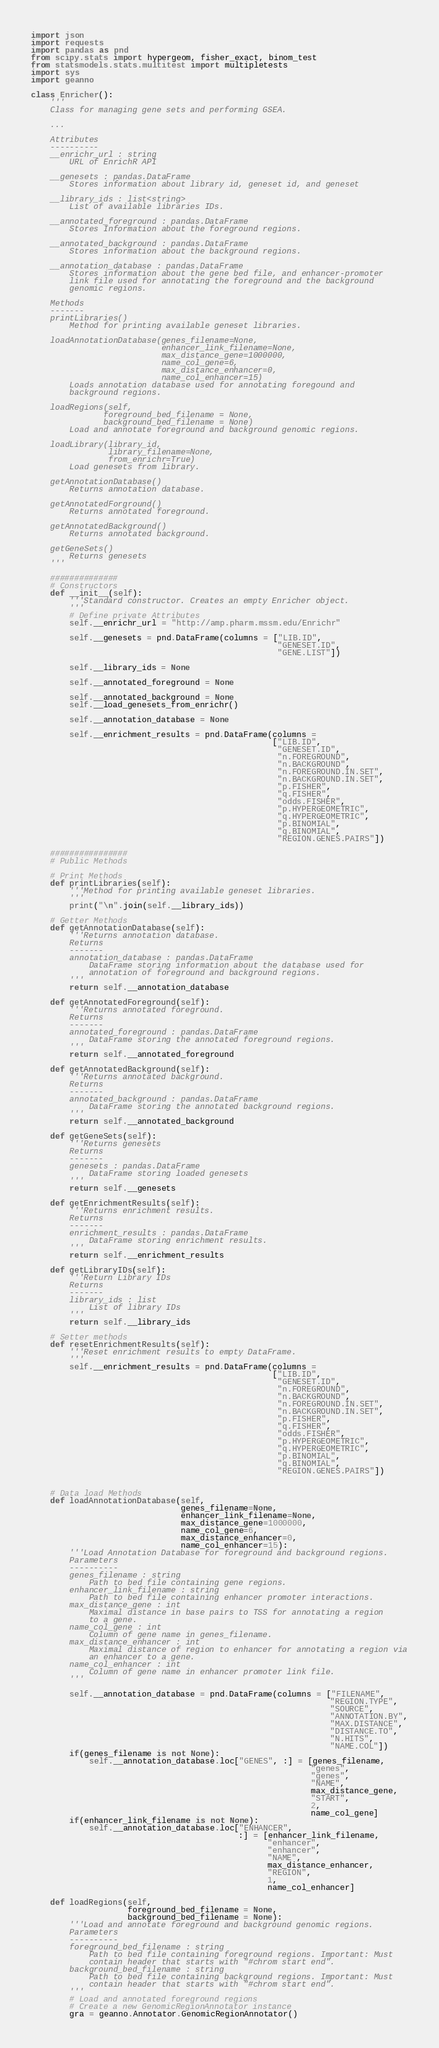<code> <loc_0><loc_0><loc_500><loc_500><_Python_>import json
import requests
import pandas as pnd
from scipy.stats import hypergeom, fisher_exact, binom_test
from statsmodels.stats.multitest import multipletests
import sys
import geanno

class Enricher():
    '''
    Class for managing gene sets and performing GSEA.

    ...

    Attributes
    ----------
    __enrichr_url : string
        URL of EnrichR API

    __genesets : pandas.DataFrame
        Stores information about library id, geneset id, and geneset

    __library_ids : list<string>
        List of available libraries IDs.

    __annotated_foreground : pandas.DataFrame
        Stores Information about the foreground regions.

    __annotated_background : pandas.DataFrame
        Stores information about the background regions.

    __annotation_database : pandas.DataFrame
        Stores information about the gene bed file, and enhancer-promoter
        link file used for annotating the foreground and the background 
        genomic regions.

    Methods
    -------
    printLibraries()
        Method for printing available geneset libraries.

    loadAnnotationDatabase(genes_filename=None,
                           enhancer_link_filename=None,
                           max_distance_gene=1000000,
                           name_col_gene=6,
                           max_distance_enhancer=0,
                           name_col_enhancer=15)
        Loads annotation database used for annotating foregound and
        background regions.

    loadRegions(self,
               foreground_bed_filename = None,
               background_bed_filename = None)
        Load and annotate foreground and background genomic regions.

    loadLibrary(library_id,
                library_filename=None,
                from_enrichr=True)
        Load genesets from library.

    getAnnotationDatabase()
        Returns annotation database.

    getAnnotatedForground()
        Returns annotated foreground.

    getAnnotatedBackground()
        Returns annotated background.

    getGeneSets()
        Returns genesets
    '''

    ##############
    # Constructors
    def __init__(self):
        '''Standard constructor. Creates an empty Enricher object.
        '''
        # Define private Attributes
        self.__enrichr_url = "http://amp.pharm.mssm.edu/Enrichr"

        self.__genesets = pnd.DataFrame(columns = ["LIB.ID", 
                                                   "GENESET.ID", 
                                                   "GENE.LIST"])

        self.__library_ids = None

        self.__annotated_foreground = None

        self.__annotated_background = None
        self.__load_genesets_from_enrichr()

        self.__annotation_database = None

        self.__enrichment_results = pnd.DataFrame(columns = 
                                                  ["LIB.ID",
                                                   "GENESET.ID",
                                                   "n.FOREGROUND",
                                                   "n.BACKGROUND",
                                                   "n.FOREGROUND.IN.SET",
                                                   "n.BACKGROUND.IN.SET",
                                                   "p.FISHER",
                                                   "q.FISHER",
                                                   "odds.FISHER",
                                                   "p.HYPERGEOMETRIC",
                                                   "q.HYPERGEOMETRIC",
                                                   "p.BINOMIAL",
                                                   "q.BINOMIAL",
                                                   "REGION.GENES.PAIRS"])

    ################
    # Public Methods

    # Print Methods
    def printLibraries(self):
        '''Method for printing available geneset libraries.
        '''
        print("\n".join(self.__library_ids))

    # Getter Methods
    def getAnnotationDatabase(self):
        '''Returns annotation database.
        Returns
        -------
        annotation_database : pandas.DataFrame
            DataFrame storing information about the database used for
            annotation of foreground and background regions.
        '''
        return self.__annotation_database

    def getAnnotatedForeground(self):
        '''Returns annotated foreground.
        Returns
        -------
        annotated_foreground : pandas.DataFrame
            DataFrame storing the annotated foreground regions.
        '''
        return self.__annotated_foreground

    def getAnnotatedBackground(self):
        '''Returns annotated background.
        Returns
        -------
        annotated_background : pandas.DataFrame
            DataFrame storing the annotated background regions.
        '''
        return self.__annotated_background

    def getGeneSets(self):
        '''Returns genesets
        Returns
        -------
        genesets : pandas.DataFrame
            DataFrame storing loaded genesets
        '''
        return self.__genesets

    def getEnrichmentResults(self):
        '''Returns enrichment results.
        Returns
        -------
        enrichment_results : pandas.DataFrame
            DataFrame storing enrichment results.
        '''
        return self.__enrichment_results

    def getLibraryIDs(self):
        '''Return Library IDs
        Returns
        -------
        library_ids : list
            List of library IDs
        '''
        return self.__library_ids

    # Setter methods
    def resetEnrichmentResults(self):
        '''Reset enrichment results to empty DataFrame.
        '''
        self.__enrichment_results = pnd.DataFrame(columns = 
                                                  ["LIB.ID",
                                                   "GENESET.ID",
                                                   "n.FOREGROUND",
                                                   "n.BACKGROUND",
                                                   "n.FOREGROUND.IN.SET",
                                                   "n.BACKGROUND.IN.SET",
                                                   "p.FISHER",
                                                   "q.FISHER",
                                                   "odds.FISHER",
                                                   "p.HYPERGEOMETRIC",
                                                   "q.HYPERGEOMETRIC",
                                                   "p.BINOMIAL",
                                                   "q.BINOMIAL",
                                                   "REGION.GENES.PAIRS"])


    # Data load Methods
    def loadAnnotationDatabase(self,
                               genes_filename=None,
                               enhancer_link_filename=None,
                               max_distance_gene=1000000,
                               name_col_gene=6,
                               max_distance_enhancer=0,
                               name_col_enhancer=15):
        '''Load Annotation Database for foreground and background regions.
        Parameters
        ----------
        genes_filename : string
            Path to bed file containing gene regions.
        enhancer_link_filename : string
            Path to bed file containing enhancer promoter interactions.
        max_distance_gene : int
            Maximal distance in base pairs to TSS for annotating a region
            to a gene.
        name_col_gene : int
            Column of gene name in genes_filename.
        max_distance_enhancer : int
            Maximal distance of region to enhancer for annotating a region via
            an enhancer to a gene.
        name_col_enhancer : int
            Column of gene name in enhancer promoter link file.
        '''

        self.__annotation_database = pnd.DataFrame(columns = ["FILENAME",
                                                              "REGION.TYPE",
                                                              "SOURCE",
                                                              "ANNOTATION.BY",
                                                              "MAX.DISTANCE",
                                                              "DISTANCE.TO",
                                                              "N.HITS",
                                                              "NAME.COL"])
        if(genes_filename is not None):
            self.__annotation_database.loc["GENES", :] = [genes_filename,
                                                          "genes",
                                                          "genes",
                                                          "NAME",
                                                          max_distance_gene,
                                                          "START",
                                                          2,
                                                          name_col_gene]
        if(enhancer_link_filename is not None):
            self.__annotation_database.loc["ENHANCER",
                                           :] = [enhancer_link_filename,
                                                 "enhancer",
                                                 "enhancer",
                                                 "NAME",
                                                 max_distance_enhancer,
                                                 "REGION",
                                                 1,
                                                 name_col_enhancer]

    def loadRegions(self,
                    foreground_bed_filename = None,
                    background_bed_filename = None):
        '''Load and annotate foreground and background genomic regions.
        Parameters
        ----------
        foreground_bed_filename : string
            Path to bed file containing foreground regions. Important: Must
            contain header that starts with "#chrom start end".
        background_bed_filename : string
            Path to bed file containing background regions. Important: Must
            contain header that starts with "#chrom start end".
        '''
        # Load and annotated foreground regions
        # Create a new GenomicRegionAnnotator instance
        gra = geanno.Annotator.GenomicRegionAnnotator()
</code> 